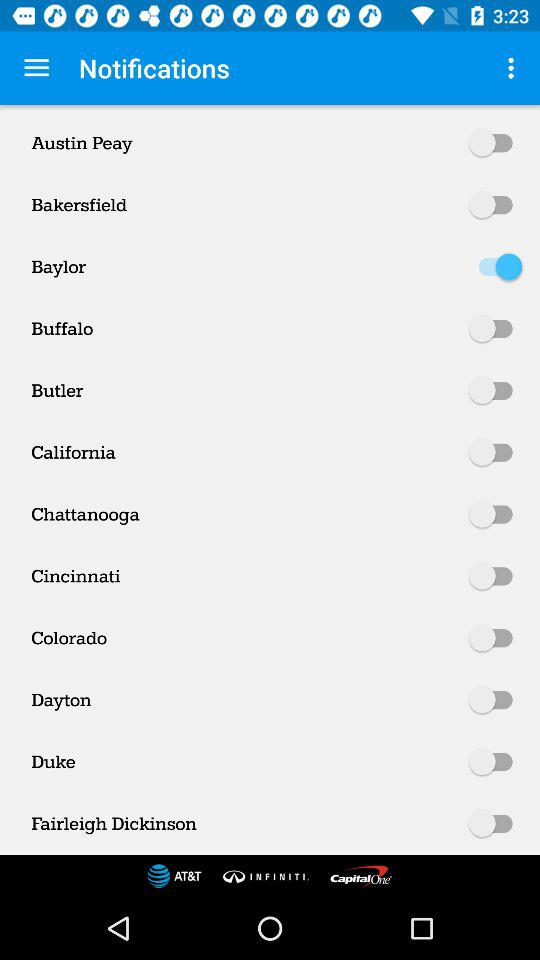What's the status of Baylor? The status is "on". 